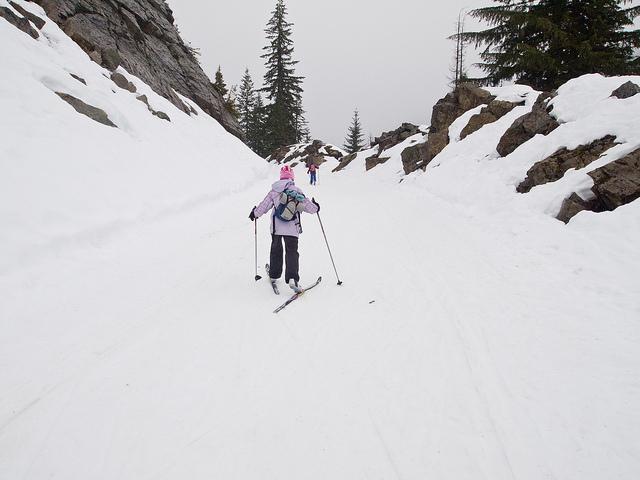Is the woman wearing purple?
Give a very brief answer. Yes. What sport is this?
Concise answer only. Skiing. What is the person looking at?
Quick response, please. Snow. Is it snowing in this picture?
Quick response, please. No. What color is the woman's hat?
Short answer required. Pink. How many skiers are in this photo?
Be succinct. 2. Is the skier touching the ground?
Quick response, please. Yes. How many people can be seen on the trail?
Be succinct. 2. 